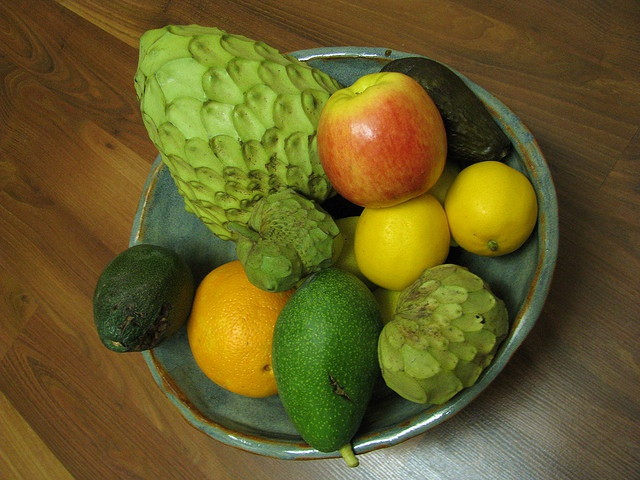Describe the objects in this image and their specific colors. I can see dining table in olive, maroon, black, and gray tones, bowl in black, olive, and darkgreen tones, apple in black, brown, orange, and red tones, and orange in black, orange, and olive tones in this image. 